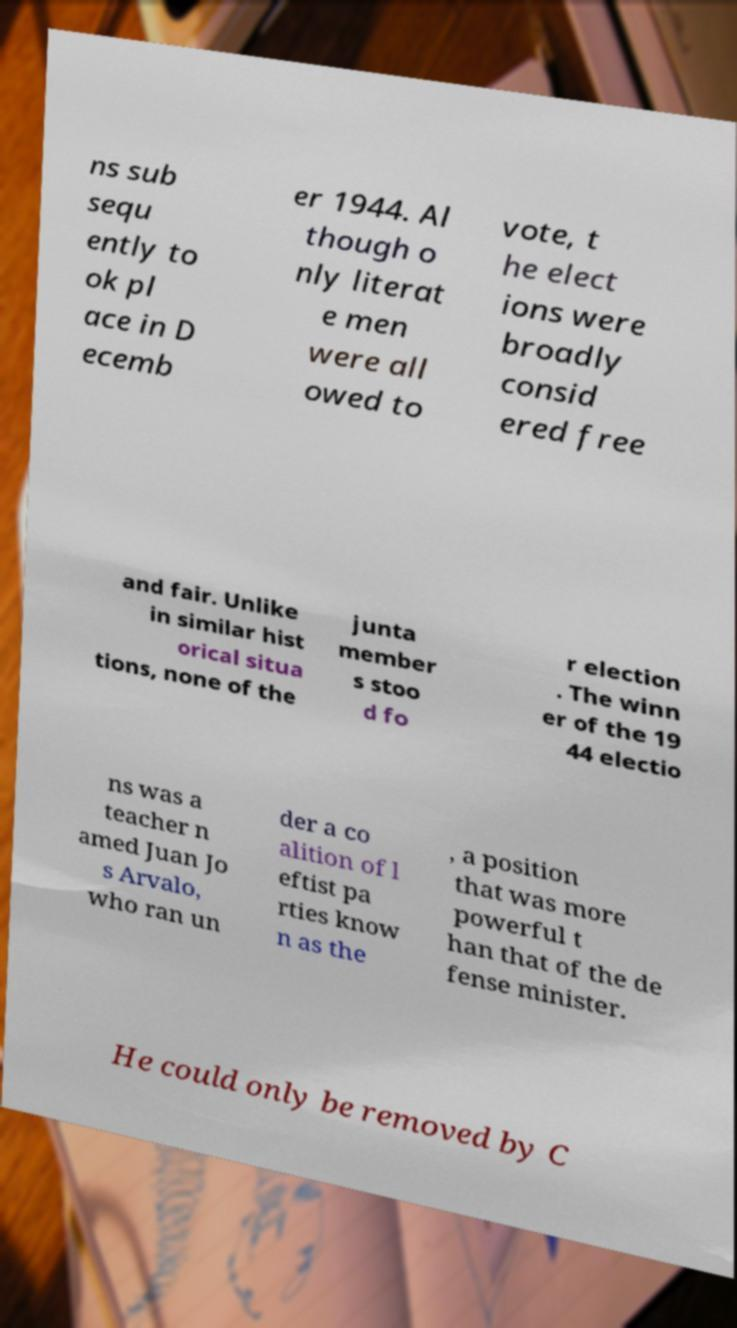Please identify and transcribe the text found in this image. ns sub sequ ently to ok pl ace in D ecemb er 1944. Al though o nly literat e men were all owed to vote, t he elect ions were broadly consid ered free and fair. Unlike in similar hist orical situa tions, none of the junta member s stoo d fo r election . The winn er of the 19 44 electio ns was a teacher n amed Juan Jo s Arvalo, who ran un der a co alition of l eftist pa rties know n as the , a position that was more powerful t han that of the de fense minister. He could only be removed by C 